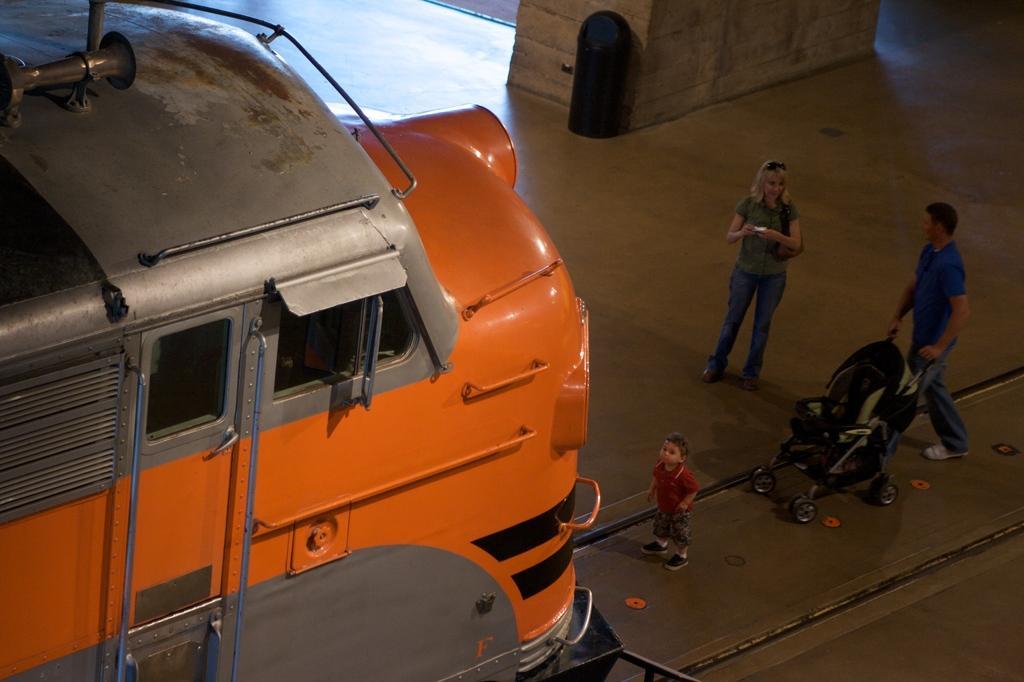Please provide a concise description of this image. There is a vehicle. Here we can see a woman, man, and a kid. He is holding a baby stroller with his hands and there is a bin. 